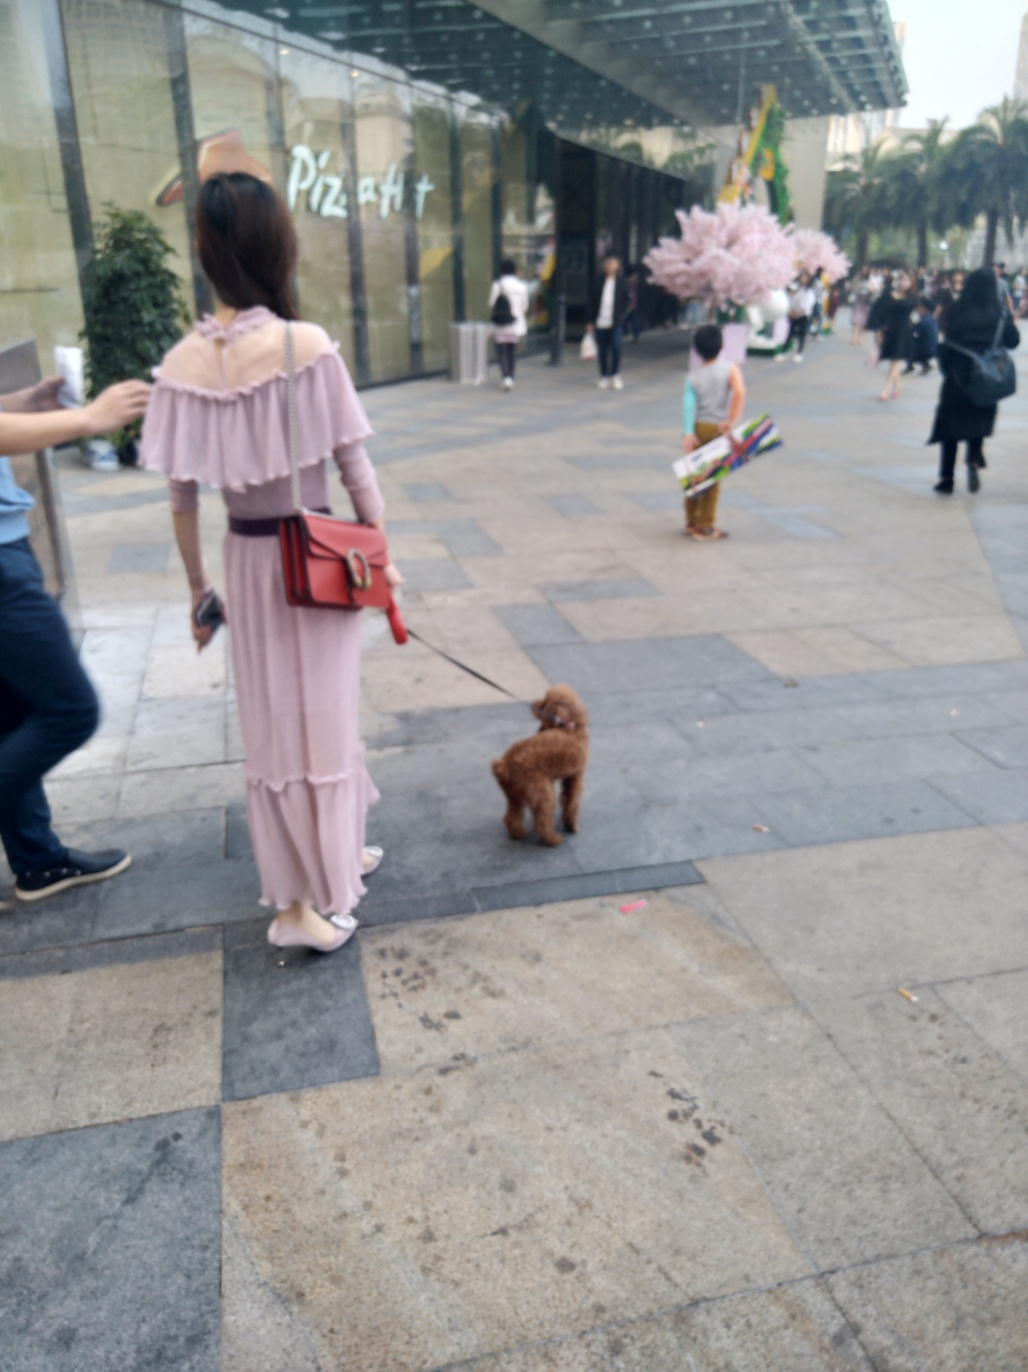Describe the atmosphere and setting of this location. The setting is an outdoor urban environment, with a pleasant and casual atmosphere. People are strolling leisurely, indicating a non-rushed mood of daily life. The presence of a shopping mall and a wide pedestrian walkway hints at a commercial and possibly a communal gathering space. 